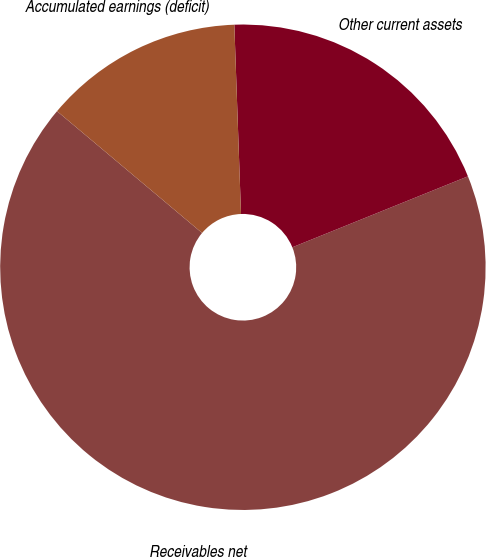Convert chart. <chart><loc_0><loc_0><loc_500><loc_500><pie_chart><fcel>Receivables net<fcel>Other current assets<fcel>Accumulated earnings (deficit)<nl><fcel>67.23%<fcel>19.45%<fcel>13.32%<nl></chart> 